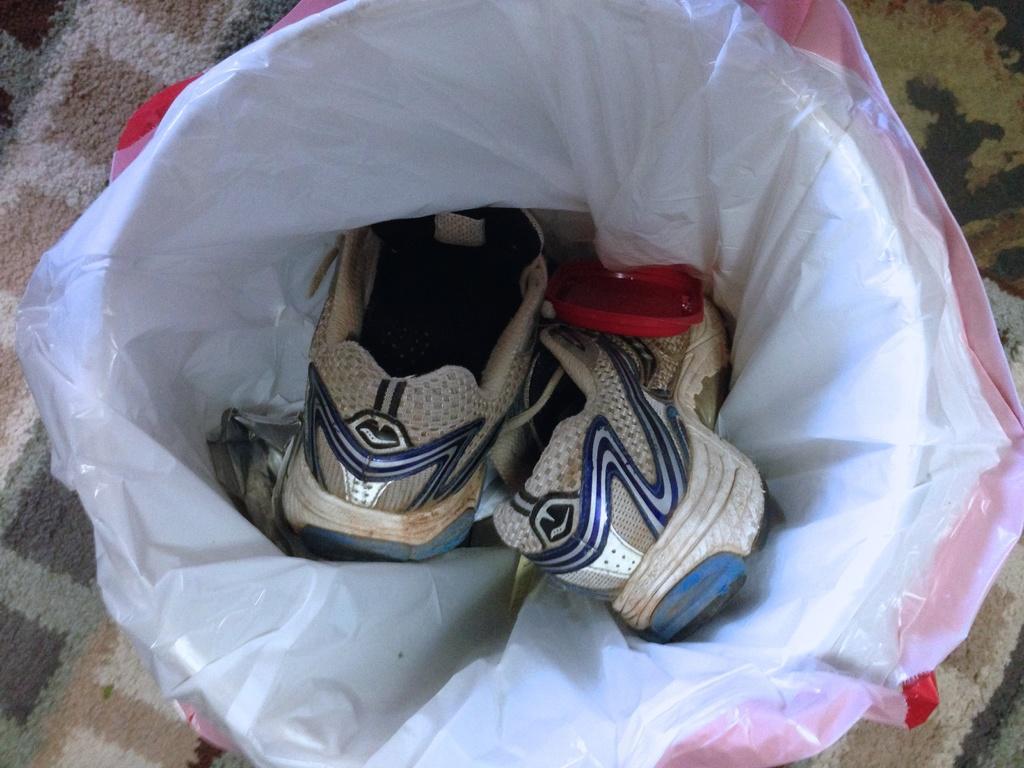Can you describe this image briefly? In this image we can see a pair of shoes in the object which is covered with the cover. In the background, we can see the mat on the surface. 